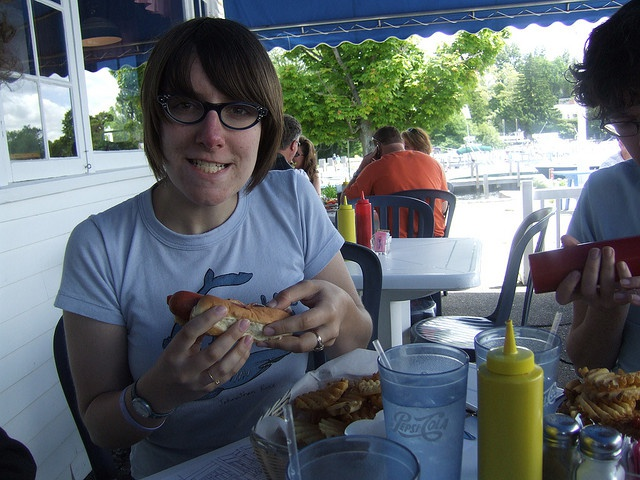Describe the objects in this image and their specific colors. I can see people in black and gray tones, dining table in black, blue, and gray tones, people in black, darkblue, gray, and navy tones, cup in black, gray, blue, and navy tones, and dining table in black, lightgray, darkgray, gray, and lightblue tones in this image. 